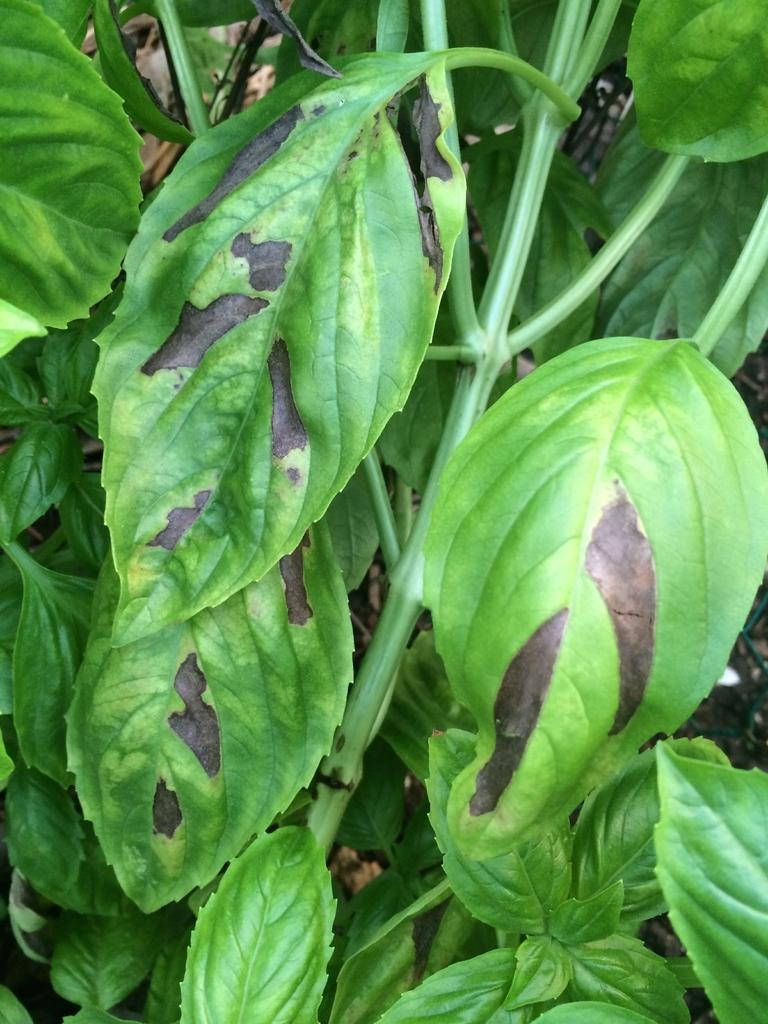What type of living organisms can be seen in the image? Plants can be seen in the image. What is the color of the leaves on the plants? The leaves of the plants are green in color. What type of toothpaste is being used to clean the leaves of the plants in the image? There is no toothpaste present in the image, and the leaves of the plants are not being cleaned. 